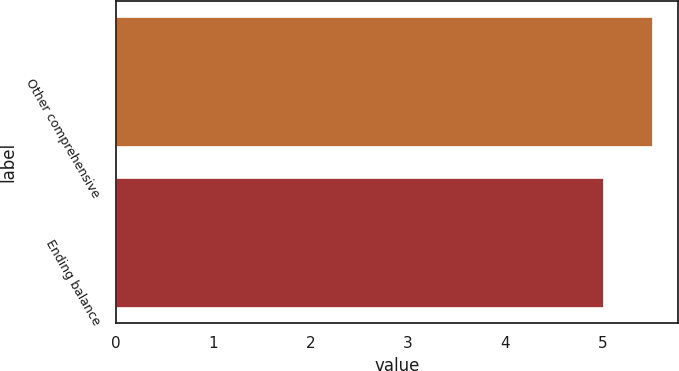<chart> <loc_0><loc_0><loc_500><loc_500><bar_chart><fcel>Other comprehensive<fcel>Ending balance<nl><fcel>5.5<fcel>5<nl></chart> 